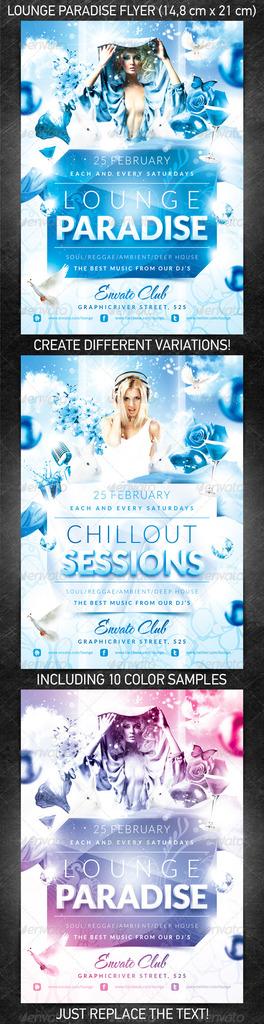When is the event?
Ensure brevity in your answer.  25 february. What is the name of the event?
Make the answer very short. Lounge paradise. 